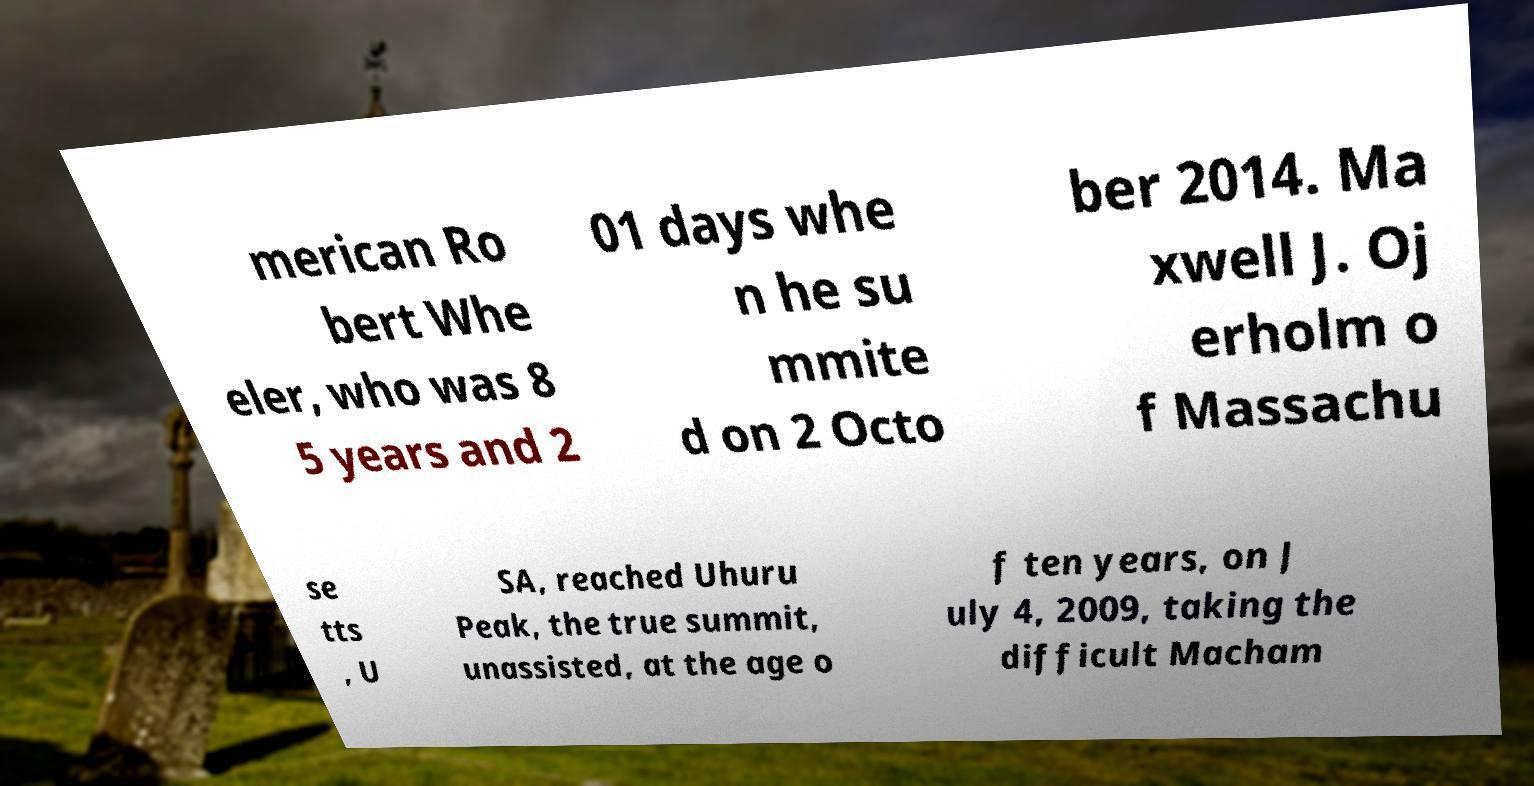There's text embedded in this image that I need extracted. Can you transcribe it verbatim? merican Ro bert Whe eler, who was 8 5 years and 2 01 days whe n he su mmite d on 2 Octo ber 2014. Ma xwell J. Oj erholm o f Massachu se tts , U SA, reached Uhuru Peak, the true summit, unassisted, at the age o f ten years, on J uly 4, 2009, taking the difficult Macham 